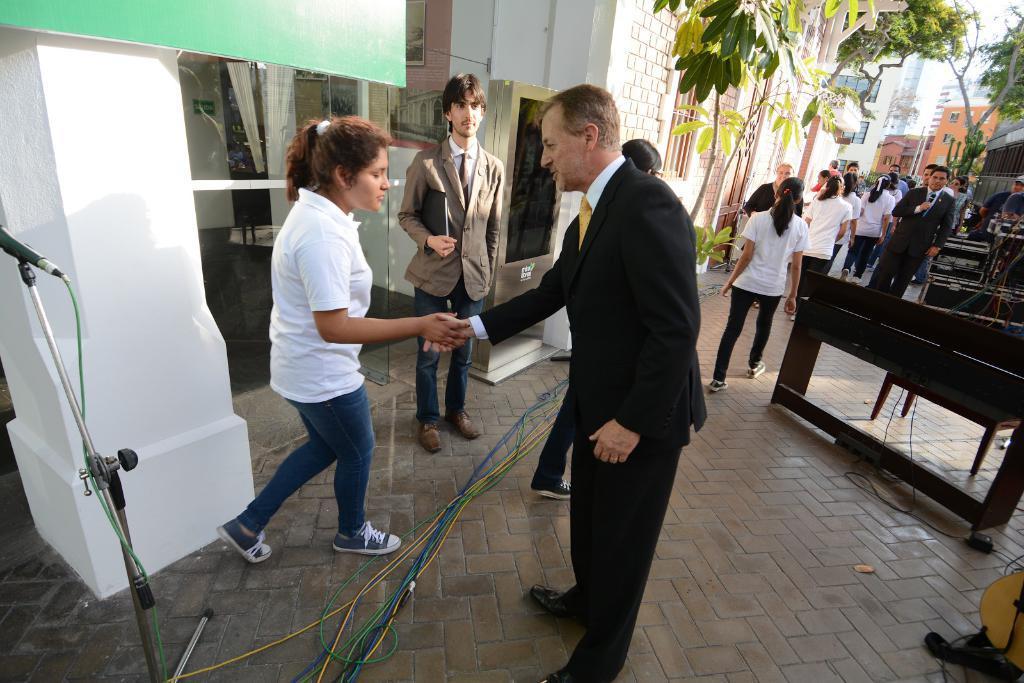In one or two sentences, can you explain what this image depicts? In this picture we can see some people are walking and some people are standing, in the background there are some trees and buildings, on the left side there is a microphone and a pillar, on the right side there are some wires, we can also see wires at the bottom. 